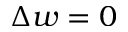<formula> <loc_0><loc_0><loc_500><loc_500>\Delta w = 0</formula> 